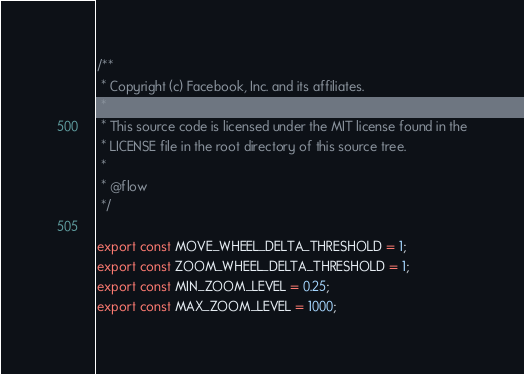<code> <loc_0><loc_0><loc_500><loc_500><_JavaScript_>/**
 * Copyright (c) Facebook, Inc. and its affiliates.
 *
 * This source code is licensed under the MIT license found in the
 * LICENSE file in the root directory of this source tree.
 *
 * @flow
 */

export const MOVE_WHEEL_DELTA_THRESHOLD = 1;
export const ZOOM_WHEEL_DELTA_THRESHOLD = 1;
export const MIN_ZOOM_LEVEL = 0.25;
export const MAX_ZOOM_LEVEL = 1000;
</code> 